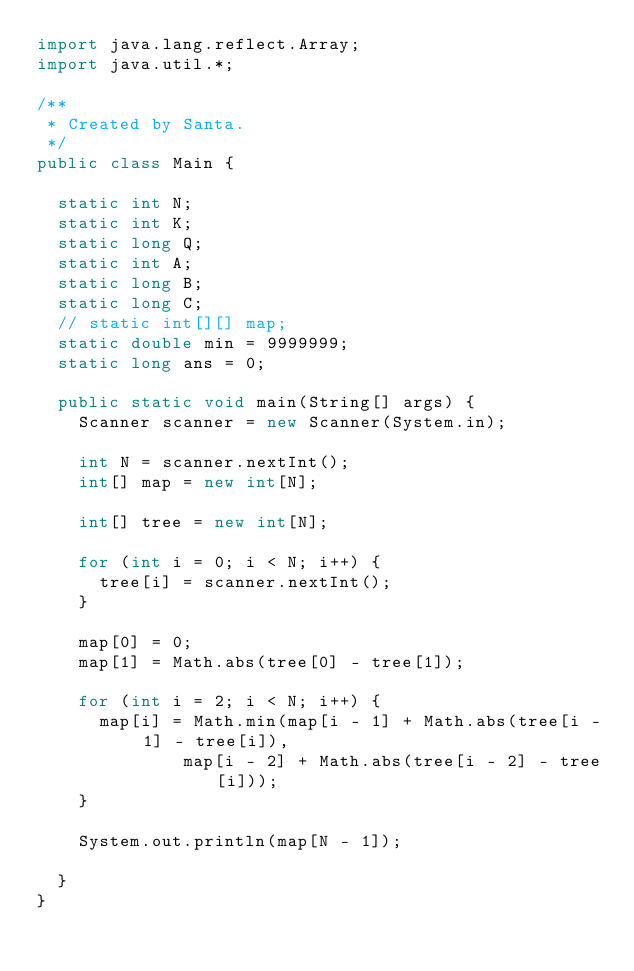Convert code to text. <code><loc_0><loc_0><loc_500><loc_500><_Java_>import java.lang.reflect.Array;
import java.util.*;

/**
 * Created by Santa.
 */
public class Main {

  static int N;
  static int K;
  static long Q;
  static int A;
  static long B;
  static long C;
  // static int[][] map;
  static double min = 9999999;
  static long ans = 0;

  public static void main(String[] args) {
    Scanner scanner = new Scanner(System.in);

    int N = scanner.nextInt();
    int[] map = new int[N];

    int[] tree = new int[N];

    for (int i = 0; i < N; i++) {
      tree[i] = scanner.nextInt();
    }

    map[0] = 0;
    map[1] = Math.abs(tree[0] - tree[1]);

    for (int i = 2; i < N; i++) {
      map[i] = Math.min(map[i - 1] + Math.abs(tree[i - 1] - tree[i]),
              map[i - 2] + Math.abs(tree[i - 2] - tree[i]));
    }

    System.out.println(map[N - 1]);

  }
}
</code> 